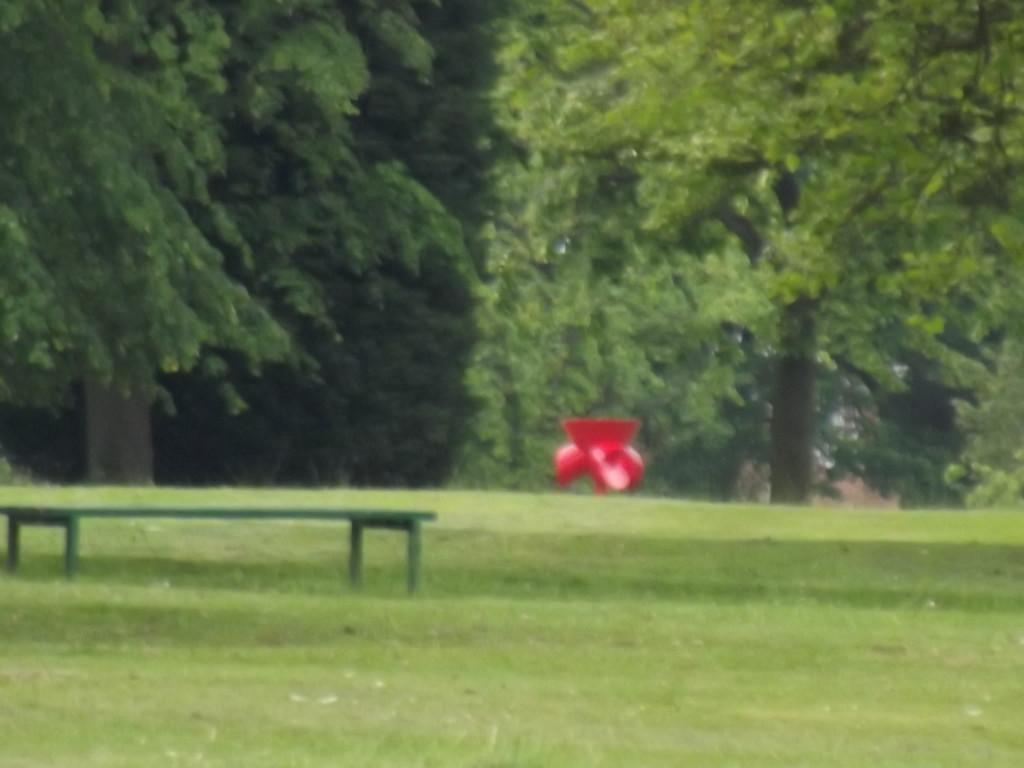What type of seating is visible in the image? There is a bench in the image. Where is the bench located? The bench is on the surface of the grass. What color is the object in the image? There is an object in red color in the image. What can be seen in the background of the image? There are trees in the background of the image. What type of building can be seen in the alley behind the bench? There is no alley or building present in the image; it only features a bench on the grass and trees in the background. 